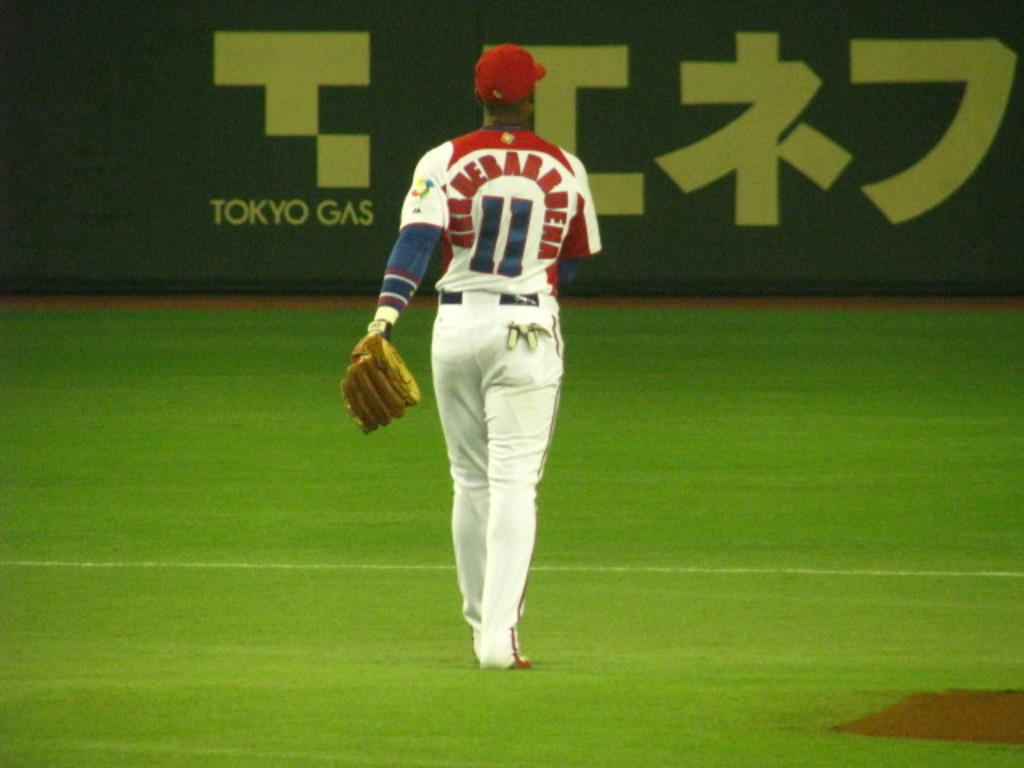Who is the main subject in the picture? There is a person in the center of the picture. What is the person wearing on their hand? The person is wearing a glove. What is the person doing in the image? The person is walking on the ground. What type of vegetation can be seen in the image? There is grass visible in the image. What can be seen in the background of the image? There is a board in the background of the image. What type of caption is written on the board in the background? There is no caption visible on the board in the background; it is not mentioned in the provided facts. What thrilling activity is the person participating in the image? The provided facts do not mention any thrilling activity; the person is simply walking on the ground. 